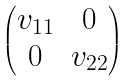<formula> <loc_0><loc_0><loc_500><loc_500>\begin{pmatrix} v _ { 1 1 } & 0 \\ 0 & v _ { 2 2 } \end{pmatrix}</formula> 